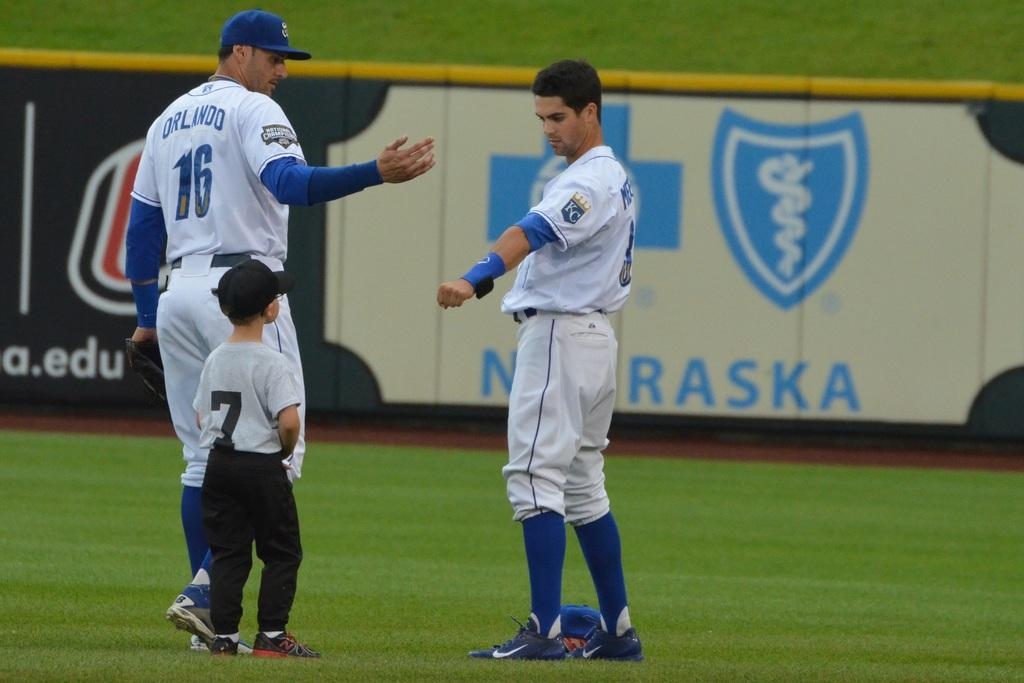<image>
Create a compact narrative representing the image presented. A child wearing jersey number 7 approached the two Kansas City Royals players near the Blue Cross Blue Shield Nebraska advertisement. 